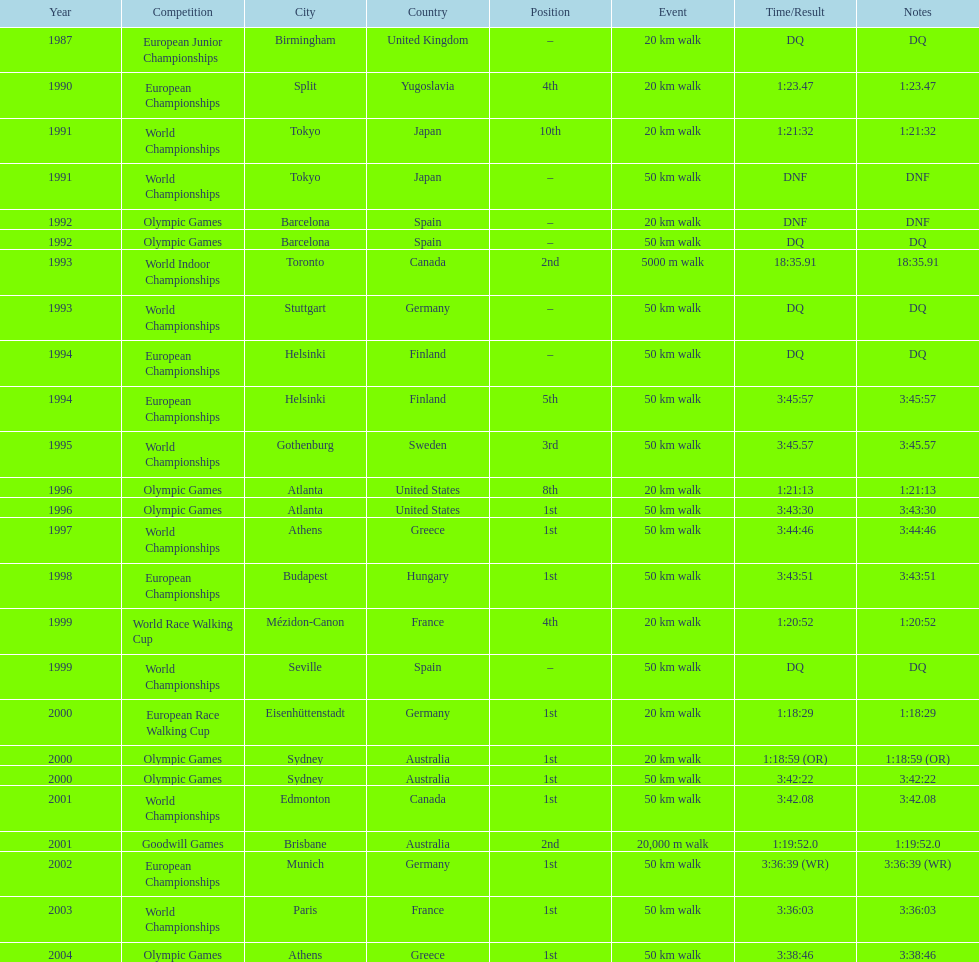What was the difference between korzeniowski's performance at the 1996 olympic games and the 2000 olympic games in the 20 km walk? 2:14. 